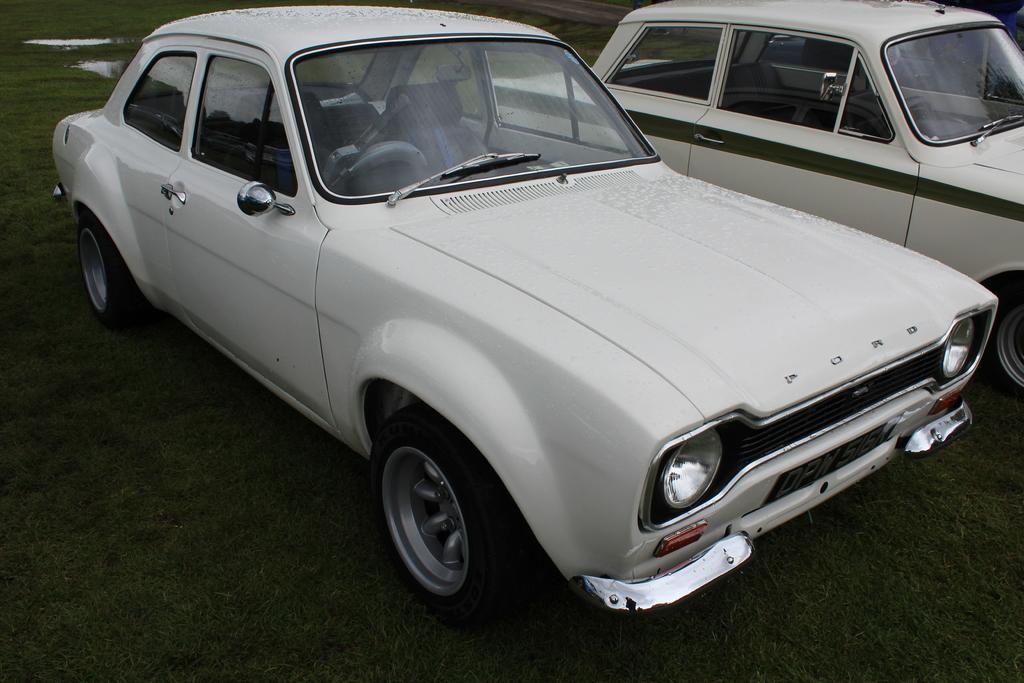Describe this image in one or two sentences. In this image I see 2 cars which are of white in color and I see a word over here and I see the green grass and I see the water over here. 